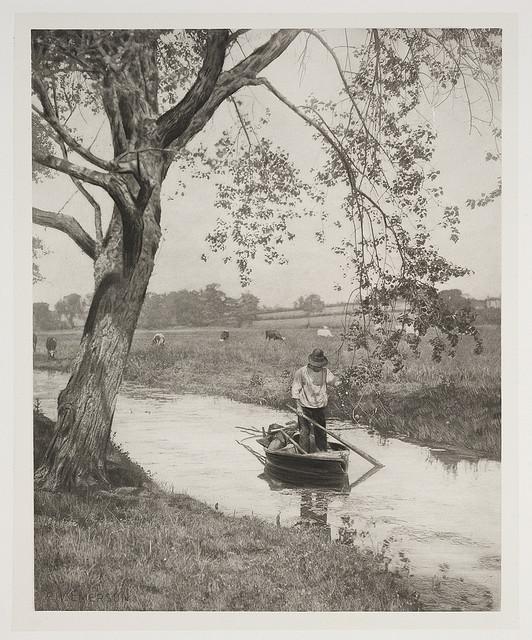Is this taken near mountains?
Concise answer only. No. Is she milking a cow?
Answer briefly. No. What type of boat is this?
Concise answer only. Canoe. Is this a large river?
Answer briefly. No. What is this guy holding?
Answer briefly. Oar. Is that a young boy on the boat?
Short answer required. Yes. What is the man standing on?
Give a very brief answer. Boat. Could the boat hold eight people?
Keep it brief. No. Is there anyone on the boat?
Be succinct. Yes. 